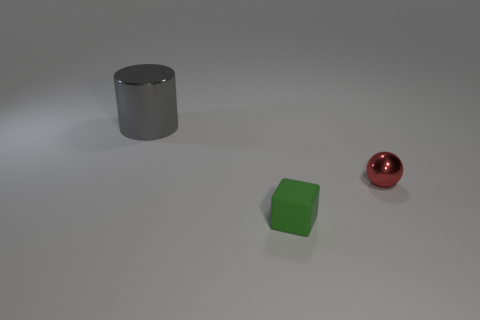Is there any other thing that has the same size as the gray object?
Provide a short and direct response. No. There is a object that is in front of the small red metal sphere; how big is it?
Your answer should be very brief. Small. There is a metallic object to the left of the metallic object that is in front of the gray cylinder; what size is it?
Provide a succinct answer. Large. What material is the green cube that is the same size as the ball?
Your answer should be very brief. Rubber. Are there any metallic cylinders to the right of the big gray shiny object?
Make the answer very short. No. Are there an equal number of small green cubes that are behind the small green cube and green objects?
Keep it short and to the point. No. What shape is the green matte object that is the same size as the red ball?
Offer a very short reply. Cube. What is the material of the small green block?
Ensure brevity in your answer.  Rubber. There is a object that is both behind the green rubber object and to the right of the big object; what is its color?
Offer a very short reply. Red. Are there an equal number of large gray cylinders right of the cube and shiny objects in front of the large gray metallic object?
Offer a terse response. No. 